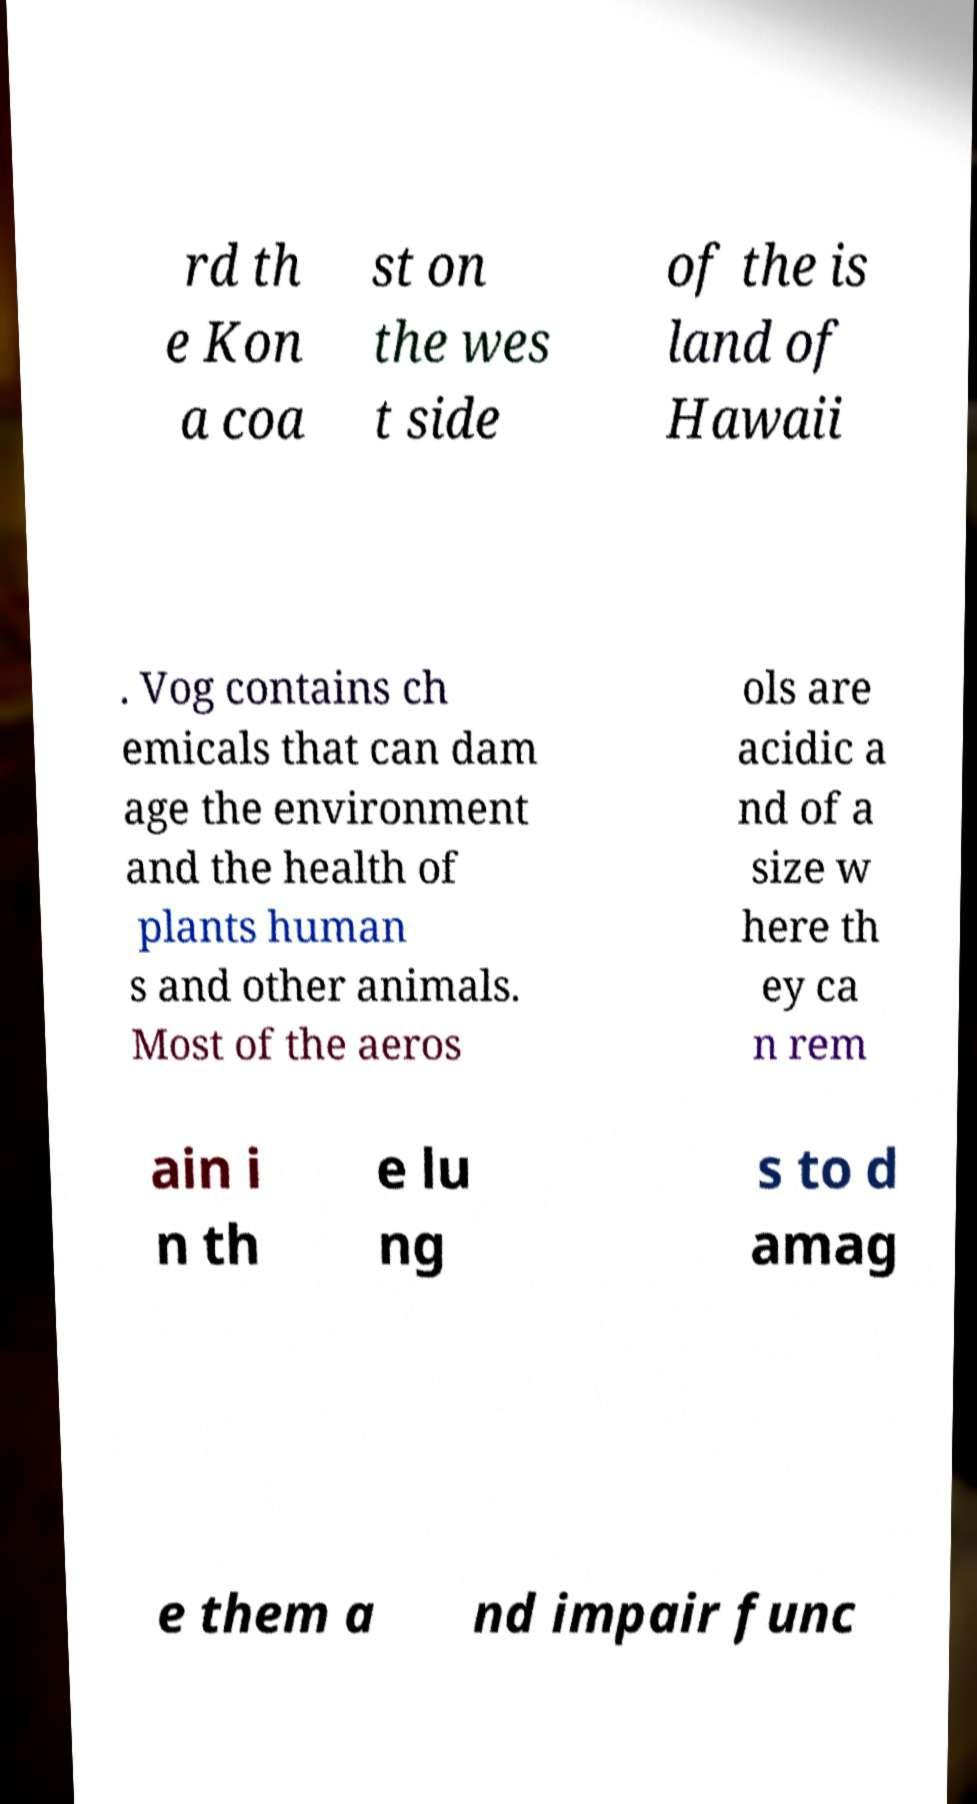There's text embedded in this image that I need extracted. Can you transcribe it verbatim? rd th e Kon a coa st on the wes t side of the is land of Hawaii . Vog contains ch emicals that can dam age the environment and the health of plants human s and other animals. Most of the aeros ols are acidic a nd of a size w here th ey ca n rem ain i n th e lu ng s to d amag e them a nd impair func 